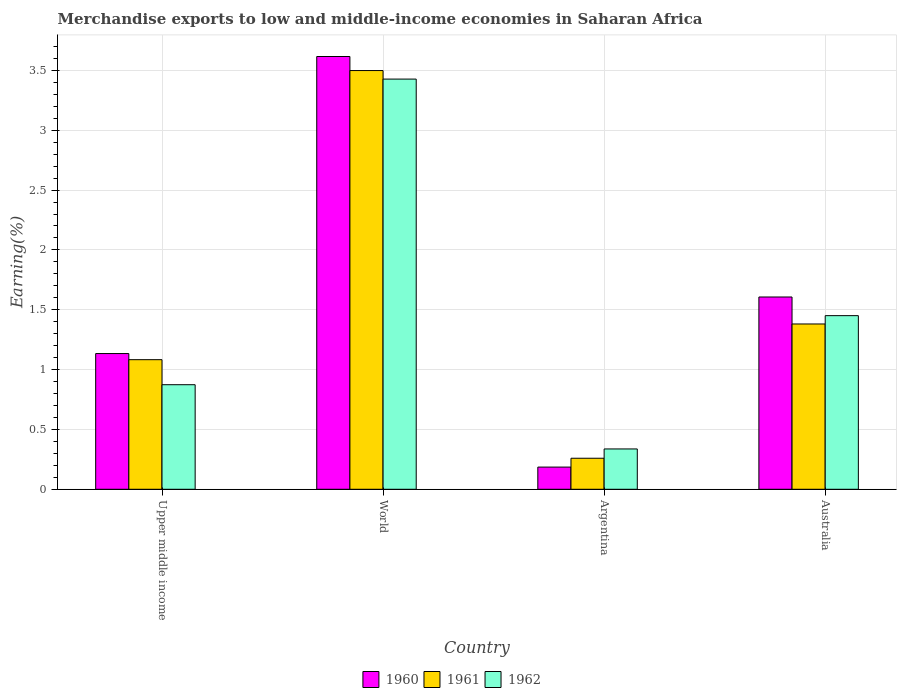How many different coloured bars are there?
Give a very brief answer. 3. How many bars are there on the 2nd tick from the right?
Provide a succinct answer. 3. What is the label of the 2nd group of bars from the left?
Your answer should be compact. World. In how many cases, is the number of bars for a given country not equal to the number of legend labels?
Your answer should be very brief. 0. What is the percentage of amount earned from merchandise exports in 1961 in Upper middle income?
Make the answer very short. 1.08. Across all countries, what is the maximum percentage of amount earned from merchandise exports in 1960?
Offer a terse response. 3.62. Across all countries, what is the minimum percentage of amount earned from merchandise exports in 1960?
Your answer should be very brief. 0.19. In which country was the percentage of amount earned from merchandise exports in 1962 maximum?
Your answer should be very brief. World. What is the total percentage of amount earned from merchandise exports in 1960 in the graph?
Offer a very short reply. 6.54. What is the difference between the percentage of amount earned from merchandise exports in 1961 in Argentina and that in Australia?
Your answer should be compact. -1.12. What is the difference between the percentage of amount earned from merchandise exports in 1960 in Australia and the percentage of amount earned from merchandise exports in 1962 in Argentina?
Offer a terse response. 1.27. What is the average percentage of amount earned from merchandise exports in 1960 per country?
Provide a succinct answer. 1.64. What is the difference between the percentage of amount earned from merchandise exports of/in 1960 and percentage of amount earned from merchandise exports of/in 1962 in Australia?
Ensure brevity in your answer.  0.16. In how many countries, is the percentage of amount earned from merchandise exports in 1961 greater than 2.5 %?
Your response must be concise. 1. What is the ratio of the percentage of amount earned from merchandise exports in 1962 in Argentina to that in World?
Ensure brevity in your answer.  0.1. Is the percentage of amount earned from merchandise exports in 1961 in Argentina less than that in World?
Your response must be concise. Yes. Is the difference between the percentage of amount earned from merchandise exports in 1960 in Australia and Upper middle income greater than the difference between the percentage of amount earned from merchandise exports in 1962 in Australia and Upper middle income?
Offer a very short reply. No. What is the difference between the highest and the second highest percentage of amount earned from merchandise exports in 1962?
Offer a very short reply. -0.58. What is the difference between the highest and the lowest percentage of amount earned from merchandise exports in 1961?
Make the answer very short. 3.24. What does the 2nd bar from the left in Upper middle income represents?
Give a very brief answer. 1961. How many bars are there?
Provide a succinct answer. 12. What is the difference between two consecutive major ticks on the Y-axis?
Make the answer very short. 0.5. Does the graph contain grids?
Your answer should be very brief. Yes. Where does the legend appear in the graph?
Provide a short and direct response. Bottom center. How many legend labels are there?
Offer a terse response. 3. What is the title of the graph?
Your answer should be compact. Merchandise exports to low and middle-income economies in Saharan Africa. What is the label or title of the Y-axis?
Provide a succinct answer. Earning(%). What is the Earning(%) in 1960 in Upper middle income?
Your answer should be compact. 1.13. What is the Earning(%) in 1961 in Upper middle income?
Make the answer very short. 1.08. What is the Earning(%) of 1962 in Upper middle income?
Provide a succinct answer. 0.87. What is the Earning(%) in 1960 in World?
Your answer should be very brief. 3.62. What is the Earning(%) in 1961 in World?
Offer a very short reply. 3.5. What is the Earning(%) in 1962 in World?
Give a very brief answer. 3.43. What is the Earning(%) in 1960 in Argentina?
Offer a very short reply. 0.19. What is the Earning(%) of 1961 in Argentina?
Keep it short and to the point. 0.26. What is the Earning(%) in 1962 in Argentina?
Offer a very short reply. 0.34. What is the Earning(%) of 1960 in Australia?
Offer a terse response. 1.61. What is the Earning(%) of 1961 in Australia?
Give a very brief answer. 1.38. What is the Earning(%) in 1962 in Australia?
Your answer should be compact. 1.45. Across all countries, what is the maximum Earning(%) of 1960?
Give a very brief answer. 3.62. Across all countries, what is the maximum Earning(%) in 1961?
Keep it short and to the point. 3.5. Across all countries, what is the maximum Earning(%) of 1962?
Offer a very short reply. 3.43. Across all countries, what is the minimum Earning(%) of 1960?
Your response must be concise. 0.19. Across all countries, what is the minimum Earning(%) of 1961?
Your answer should be very brief. 0.26. Across all countries, what is the minimum Earning(%) of 1962?
Offer a very short reply. 0.34. What is the total Earning(%) of 1960 in the graph?
Offer a very short reply. 6.54. What is the total Earning(%) in 1961 in the graph?
Provide a succinct answer. 6.22. What is the total Earning(%) of 1962 in the graph?
Your response must be concise. 6.09. What is the difference between the Earning(%) of 1960 in Upper middle income and that in World?
Give a very brief answer. -2.48. What is the difference between the Earning(%) of 1961 in Upper middle income and that in World?
Your answer should be very brief. -2.42. What is the difference between the Earning(%) in 1962 in Upper middle income and that in World?
Keep it short and to the point. -2.55. What is the difference between the Earning(%) of 1960 in Upper middle income and that in Argentina?
Make the answer very short. 0.95. What is the difference between the Earning(%) of 1961 in Upper middle income and that in Argentina?
Keep it short and to the point. 0.82. What is the difference between the Earning(%) in 1962 in Upper middle income and that in Argentina?
Offer a very short reply. 0.54. What is the difference between the Earning(%) of 1960 in Upper middle income and that in Australia?
Your response must be concise. -0.47. What is the difference between the Earning(%) in 1961 in Upper middle income and that in Australia?
Keep it short and to the point. -0.3. What is the difference between the Earning(%) in 1962 in Upper middle income and that in Australia?
Ensure brevity in your answer.  -0.58. What is the difference between the Earning(%) in 1960 in World and that in Argentina?
Ensure brevity in your answer.  3.43. What is the difference between the Earning(%) in 1961 in World and that in Argentina?
Make the answer very short. 3.24. What is the difference between the Earning(%) of 1962 in World and that in Argentina?
Your answer should be compact. 3.09. What is the difference between the Earning(%) of 1960 in World and that in Australia?
Your response must be concise. 2.01. What is the difference between the Earning(%) in 1961 in World and that in Australia?
Ensure brevity in your answer.  2.12. What is the difference between the Earning(%) in 1962 in World and that in Australia?
Your response must be concise. 1.98. What is the difference between the Earning(%) in 1960 in Argentina and that in Australia?
Offer a very short reply. -1.42. What is the difference between the Earning(%) of 1961 in Argentina and that in Australia?
Make the answer very short. -1.12. What is the difference between the Earning(%) of 1962 in Argentina and that in Australia?
Offer a terse response. -1.11. What is the difference between the Earning(%) in 1960 in Upper middle income and the Earning(%) in 1961 in World?
Your answer should be compact. -2.36. What is the difference between the Earning(%) of 1960 in Upper middle income and the Earning(%) of 1962 in World?
Your response must be concise. -2.29. What is the difference between the Earning(%) in 1961 in Upper middle income and the Earning(%) in 1962 in World?
Provide a succinct answer. -2.34. What is the difference between the Earning(%) of 1960 in Upper middle income and the Earning(%) of 1961 in Argentina?
Your response must be concise. 0.87. What is the difference between the Earning(%) in 1960 in Upper middle income and the Earning(%) in 1962 in Argentina?
Keep it short and to the point. 0.8. What is the difference between the Earning(%) in 1961 in Upper middle income and the Earning(%) in 1962 in Argentina?
Your answer should be very brief. 0.75. What is the difference between the Earning(%) of 1960 in Upper middle income and the Earning(%) of 1961 in Australia?
Provide a short and direct response. -0.25. What is the difference between the Earning(%) of 1960 in Upper middle income and the Earning(%) of 1962 in Australia?
Provide a succinct answer. -0.32. What is the difference between the Earning(%) of 1961 in Upper middle income and the Earning(%) of 1962 in Australia?
Offer a very short reply. -0.37. What is the difference between the Earning(%) of 1960 in World and the Earning(%) of 1961 in Argentina?
Make the answer very short. 3.36. What is the difference between the Earning(%) of 1960 in World and the Earning(%) of 1962 in Argentina?
Offer a very short reply. 3.28. What is the difference between the Earning(%) in 1961 in World and the Earning(%) in 1962 in Argentina?
Your answer should be very brief. 3.16. What is the difference between the Earning(%) of 1960 in World and the Earning(%) of 1961 in Australia?
Offer a very short reply. 2.23. What is the difference between the Earning(%) in 1960 in World and the Earning(%) in 1962 in Australia?
Your answer should be very brief. 2.17. What is the difference between the Earning(%) in 1961 in World and the Earning(%) in 1962 in Australia?
Your answer should be compact. 2.05. What is the difference between the Earning(%) of 1960 in Argentina and the Earning(%) of 1961 in Australia?
Keep it short and to the point. -1.2. What is the difference between the Earning(%) of 1960 in Argentina and the Earning(%) of 1962 in Australia?
Offer a terse response. -1.27. What is the difference between the Earning(%) of 1961 in Argentina and the Earning(%) of 1962 in Australia?
Provide a short and direct response. -1.19. What is the average Earning(%) in 1960 per country?
Provide a succinct answer. 1.64. What is the average Earning(%) of 1961 per country?
Offer a very short reply. 1.56. What is the average Earning(%) in 1962 per country?
Provide a short and direct response. 1.52. What is the difference between the Earning(%) in 1960 and Earning(%) in 1961 in Upper middle income?
Your answer should be very brief. 0.05. What is the difference between the Earning(%) of 1960 and Earning(%) of 1962 in Upper middle income?
Give a very brief answer. 0.26. What is the difference between the Earning(%) in 1961 and Earning(%) in 1962 in Upper middle income?
Offer a very short reply. 0.21. What is the difference between the Earning(%) of 1960 and Earning(%) of 1961 in World?
Provide a short and direct response. 0.12. What is the difference between the Earning(%) in 1960 and Earning(%) in 1962 in World?
Keep it short and to the point. 0.19. What is the difference between the Earning(%) in 1961 and Earning(%) in 1962 in World?
Offer a terse response. 0.07. What is the difference between the Earning(%) in 1960 and Earning(%) in 1961 in Argentina?
Offer a terse response. -0.07. What is the difference between the Earning(%) in 1960 and Earning(%) in 1962 in Argentina?
Ensure brevity in your answer.  -0.15. What is the difference between the Earning(%) of 1961 and Earning(%) of 1962 in Argentina?
Offer a very short reply. -0.08. What is the difference between the Earning(%) of 1960 and Earning(%) of 1961 in Australia?
Offer a terse response. 0.23. What is the difference between the Earning(%) in 1960 and Earning(%) in 1962 in Australia?
Your answer should be very brief. 0.16. What is the difference between the Earning(%) in 1961 and Earning(%) in 1962 in Australia?
Provide a short and direct response. -0.07. What is the ratio of the Earning(%) of 1960 in Upper middle income to that in World?
Your response must be concise. 0.31. What is the ratio of the Earning(%) of 1961 in Upper middle income to that in World?
Provide a succinct answer. 0.31. What is the ratio of the Earning(%) of 1962 in Upper middle income to that in World?
Provide a short and direct response. 0.25. What is the ratio of the Earning(%) in 1960 in Upper middle income to that in Argentina?
Offer a terse response. 6.12. What is the ratio of the Earning(%) of 1961 in Upper middle income to that in Argentina?
Offer a terse response. 4.18. What is the ratio of the Earning(%) in 1962 in Upper middle income to that in Argentina?
Your answer should be very brief. 2.59. What is the ratio of the Earning(%) of 1960 in Upper middle income to that in Australia?
Give a very brief answer. 0.71. What is the ratio of the Earning(%) in 1961 in Upper middle income to that in Australia?
Provide a short and direct response. 0.78. What is the ratio of the Earning(%) in 1962 in Upper middle income to that in Australia?
Give a very brief answer. 0.6. What is the ratio of the Earning(%) in 1960 in World to that in Argentina?
Offer a very short reply. 19.51. What is the ratio of the Earning(%) in 1961 in World to that in Argentina?
Provide a short and direct response. 13.49. What is the ratio of the Earning(%) in 1962 in World to that in Argentina?
Your answer should be compact. 10.17. What is the ratio of the Earning(%) in 1960 in World to that in Australia?
Your answer should be compact. 2.25. What is the ratio of the Earning(%) of 1961 in World to that in Australia?
Ensure brevity in your answer.  2.53. What is the ratio of the Earning(%) of 1962 in World to that in Australia?
Offer a very short reply. 2.36. What is the ratio of the Earning(%) in 1960 in Argentina to that in Australia?
Ensure brevity in your answer.  0.12. What is the ratio of the Earning(%) of 1961 in Argentina to that in Australia?
Provide a short and direct response. 0.19. What is the ratio of the Earning(%) in 1962 in Argentina to that in Australia?
Give a very brief answer. 0.23. What is the difference between the highest and the second highest Earning(%) of 1960?
Provide a succinct answer. 2.01. What is the difference between the highest and the second highest Earning(%) of 1961?
Ensure brevity in your answer.  2.12. What is the difference between the highest and the second highest Earning(%) in 1962?
Your response must be concise. 1.98. What is the difference between the highest and the lowest Earning(%) of 1960?
Your response must be concise. 3.43. What is the difference between the highest and the lowest Earning(%) in 1961?
Your response must be concise. 3.24. What is the difference between the highest and the lowest Earning(%) in 1962?
Keep it short and to the point. 3.09. 